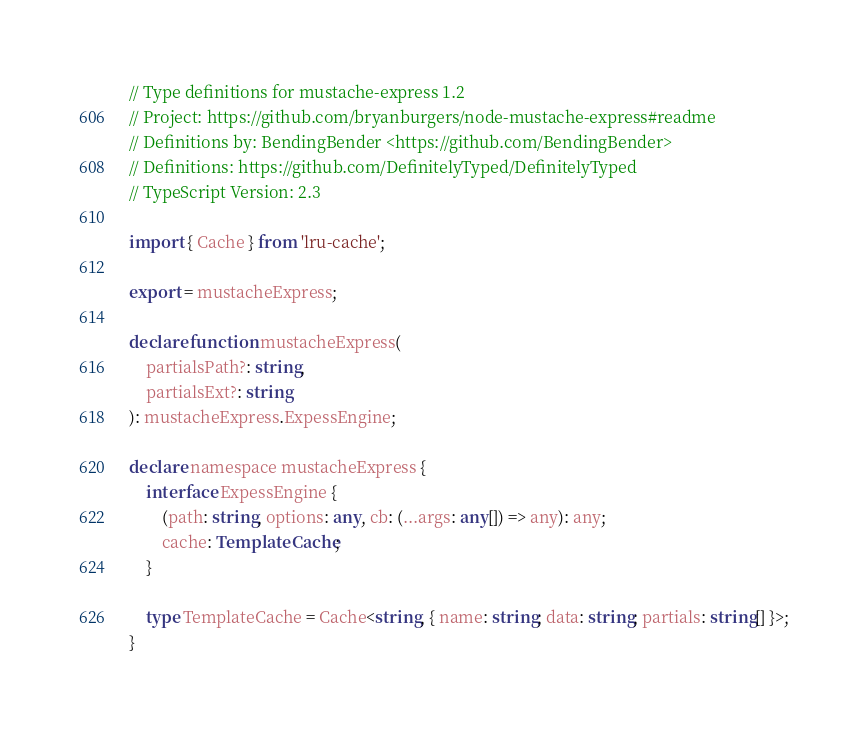Convert code to text. <code><loc_0><loc_0><loc_500><loc_500><_TypeScript_>// Type definitions for mustache-express 1.2
// Project: https://github.com/bryanburgers/node-mustache-express#readme
// Definitions by: BendingBender <https://github.com/BendingBender>
// Definitions: https://github.com/DefinitelyTyped/DefinitelyTyped
// TypeScript Version: 2.3

import { Cache } from 'lru-cache';

export = mustacheExpress;

declare function mustacheExpress(
    partialsPath?: string,
    partialsExt?: string
): mustacheExpress.ExpessEngine;

declare namespace mustacheExpress {
    interface ExpessEngine {
        (path: string, options: any, cb: (...args: any[]) => any): any;
        cache: TemplateCache;
    }

    type TemplateCache = Cache<string, { name: string; data: string; partials: string[] }>;
}
</code> 